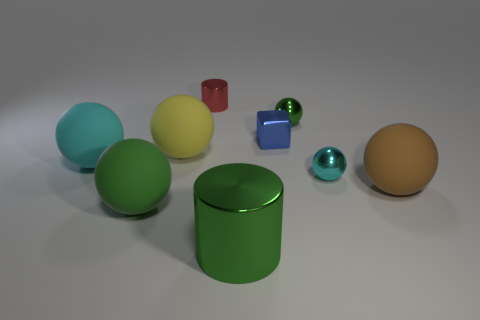Subtract all brown spheres. How many spheres are left? 5 Subtract all cyan balls. How many balls are left? 4 Subtract all yellow balls. Subtract all brown cubes. How many balls are left? 5 Subtract all blocks. How many objects are left? 8 Subtract all large yellow rubber balls. Subtract all cyan metal cubes. How many objects are left? 8 Add 1 small red things. How many small red things are left? 2 Add 2 small red objects. How many small red objects exist? 3 Subtract 0 purple cylinders. How many objects are left? 9 